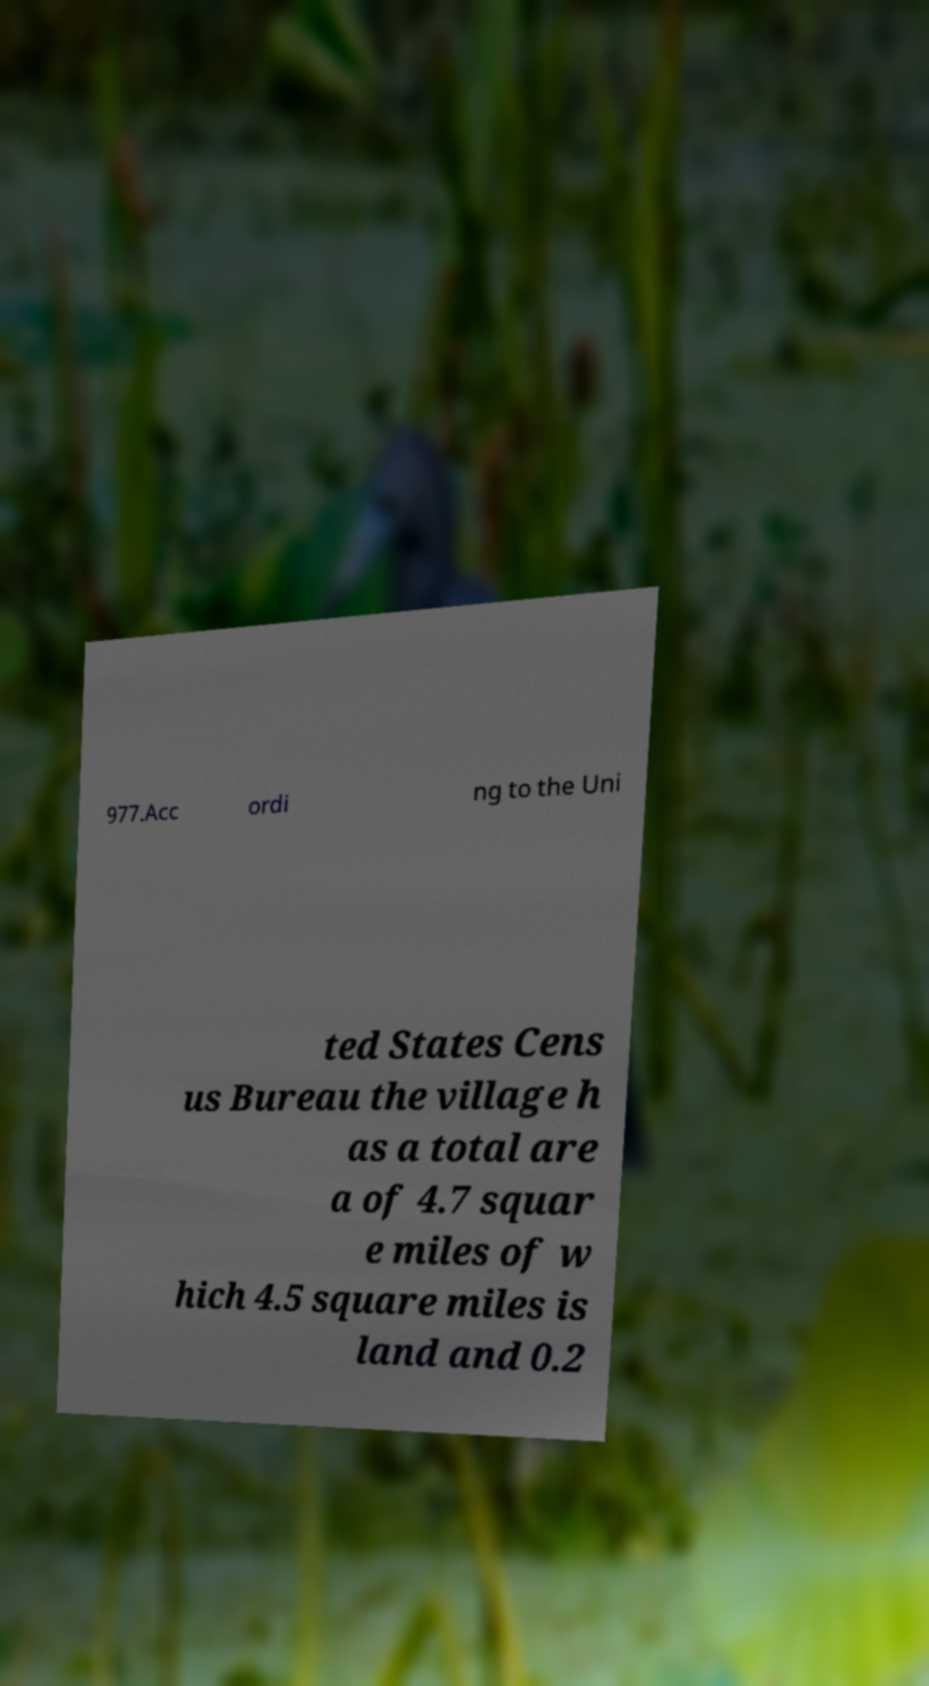Could you assist in decoding the text presented in this image and type it out clearly? 977.Acc ordi ng to the Uni ted States Cens us Bureau the village h as a total are a of 4.7 squar e miles of w hich 4.5 square miles is land and 0.2 